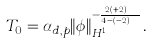Convert formula to latex. <formula><loc_0><loc_0><loc_500><loc_500>T _ { 0 } = \alpha _ { d , p } \| \phi \| _ { { H } ^ { 1 } } ^ { - \frac { 2 p ( p + 2 ) } { 4 - ( d - 2 ) p } } .</formula> 